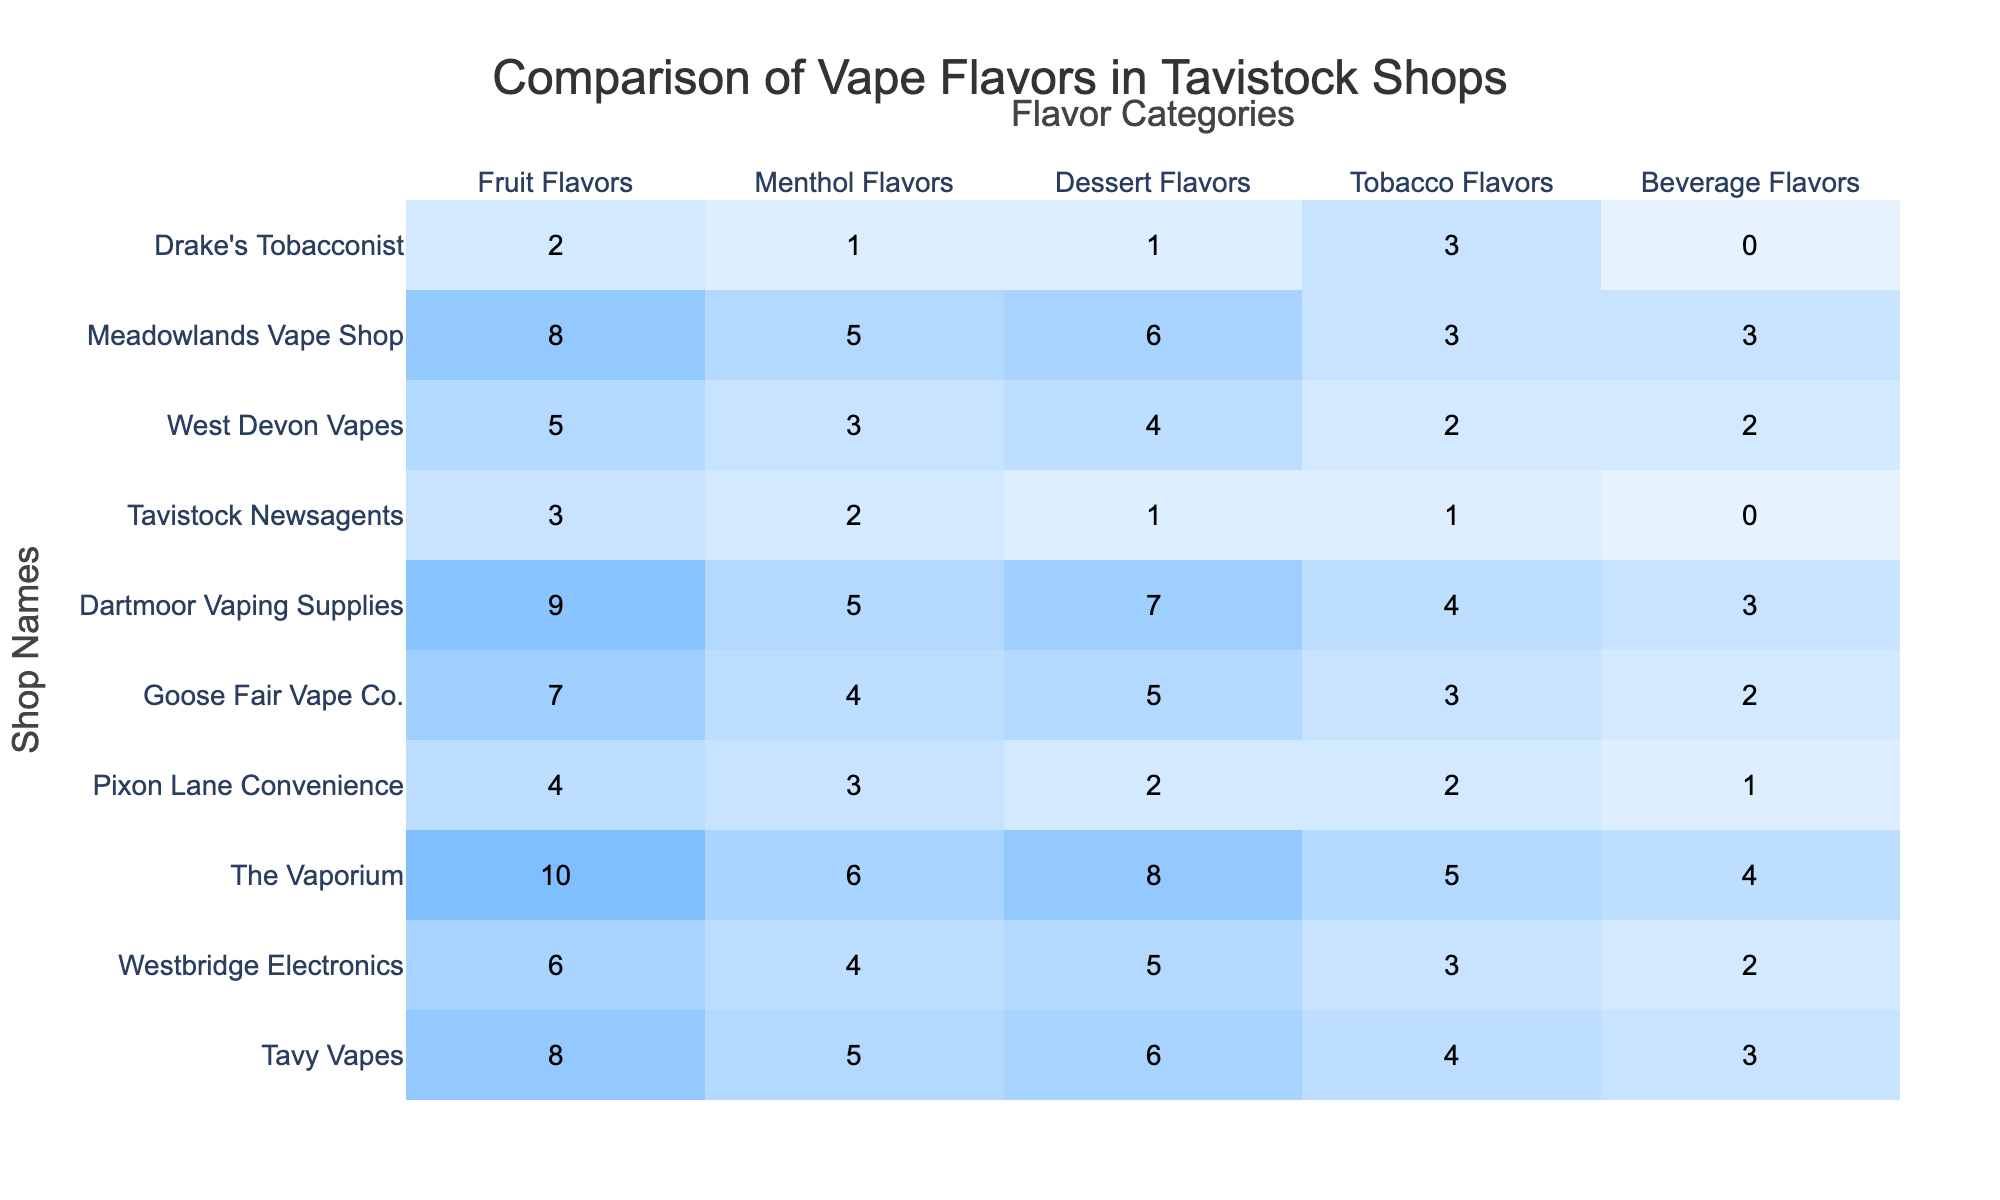What shop has the highest variety of fruit flavors? By examining the 'Fruit Flavors' column, it is evident that The Vaporium has the highest number at 10.
Answer: The Vaporium Which shop has the least number of dessert flavors? Looking at the 'Dessert Flavors' column, Tavistock Newsagents has the lowest number, which is 1.
Answer: Tavistock Newsagents How many more tobacco flavors does Tavy Vapes have compared to Pixon Lane Convenience? Tavy Vapes has 4 tobacco flavors while Pixon Lane Convenience has 2. The difference is 4 - 2 = 2.
Answer: 2 What is the total number of menthol flavors across all shops? To find the total, sum the values in the 'Menthol Flavors' column: 5 + 4 + 6 + 3 + 4 + 5 + 2 + 3 + 5 + 1 = 38.
Answer: 38 Which shop provides the same number of beverage flavors as Westbridge Electronics? Westbridge Electronics has 2 beverage flavors. Looking at the table, Pixon Lane Convenience also has 2 beverage flavors.
Answer: Pixon Lane Convenience Does Dartmoor Vaping Supplies have more fruit flavors than Tobacco flavors? Dartmoor Vaping Supplies has 9 fruit flavors and 4 tobacco flavors. Since 9 is greater than 4, the answer is yes.
Answer: Yes What is the average number of menthol flavors available across all shops? There are 10 shops in total. The sum of menthol flavors is 5 + 4 + 6 + 3 + 4 + 5 + 2 + 3 + 5 + 1 = 38. The average is 38 / 10 = 3.8.
Answer: 3.8 Which two shops offer the same number of dessert flavors? Checking the 'Dessert Flavors' column, both Tavy Vapes and Meadowlands Vape Shop offer 6 dessert flavors each.
Answer: Tavy Vapes and Meadowlands Vape Shop Find the shop with the most varied flavor categories overall. To determine this, sum the flavors from all categories for each shop and compare: The Vaporium totals 33, Tavy Vapes totals 26, Dartmoor Vaping Supplies totals 28, etc. The shop with the highest total is The Vaporium, with 33.
Answer: The Vaporium Is there any shop that does not have any beverage flavors? By looking at the 'Beverage Flavors' column, Tavistock Newsagents has 0 beverage flavors, confirming that it does not offer any.
Answer: Yes 